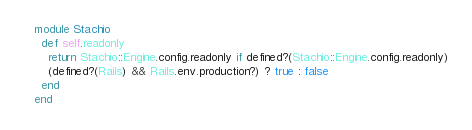Convert code to text. <code><loc_0><loc_0><loc_500><loc_500><_Ruby_>module Stachio
  def self.readonly
    return Stachio::Engine.config.readonly if defined?(Stachio::Engine.config.readonly)
    (defined?(Rails) && Rails.env.production?) ? true : false
  end
end
</code> 